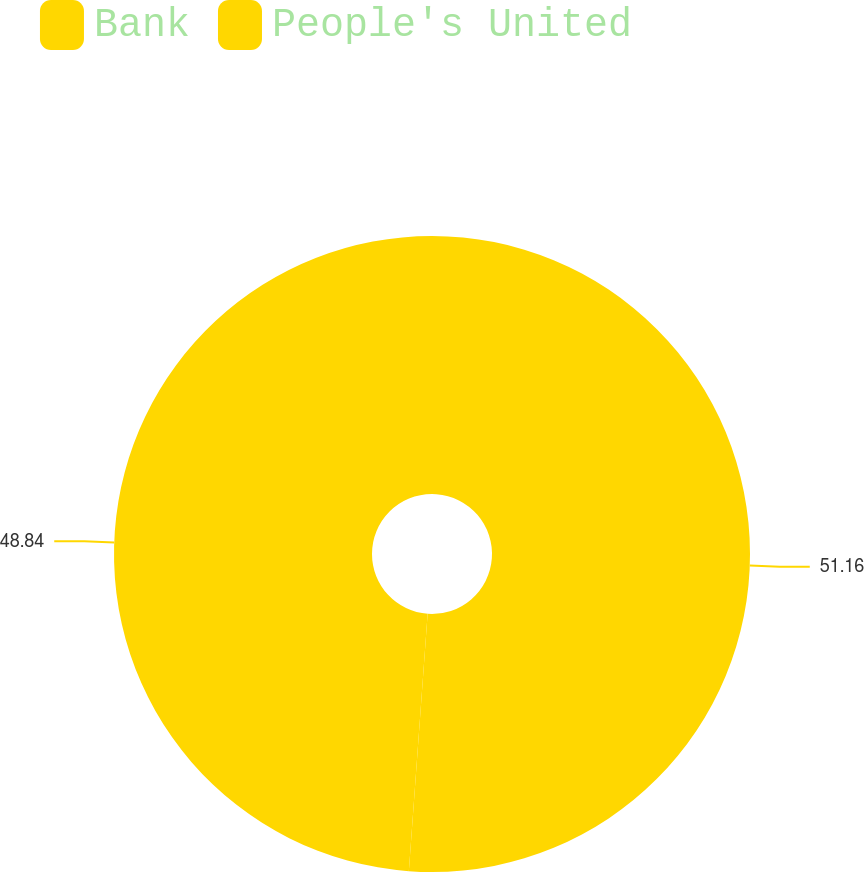<chart> <loc_0><loc_0><loc_500><loc_500><pie_chart><fcel>Bank<fcel>People's United<nl><fcel>51.16%<fcel>48.84%<nl></chart> 